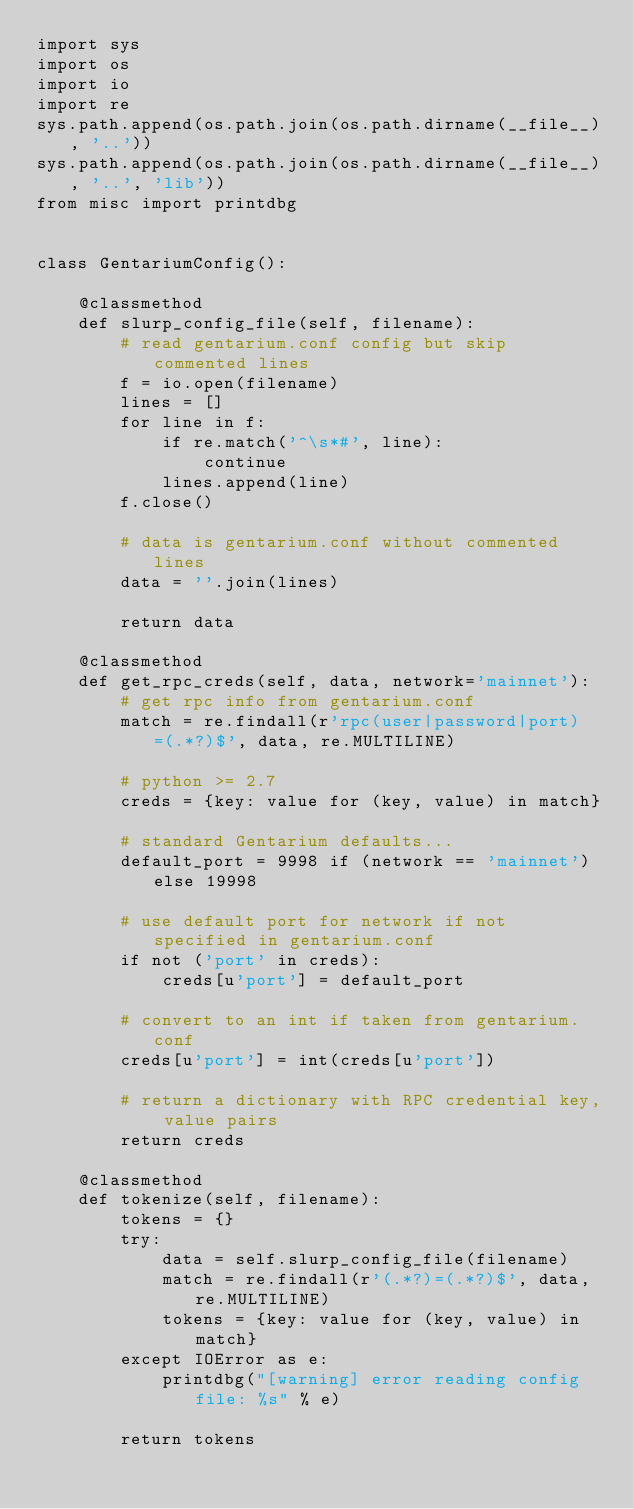<code> <loc_0><loc_0><loc_500><loc_500><_Python_>import sys
import os
import io
import re
sys.path.append(os.path.join(os.path.dirname(__file__), '..'))
sys.path.append(os.path.join(os.path.dirname(__file__), '..', 'lib'))
from misc import printdbg


class GentariumConfig():

    @classmethod
    def slurp_config_file(self, filename):
        # read gentarium.conf config but skip commented lines
        f = io.open(filename)
        lines = []
        for line in f:
            if re.match('^\s*#', line):
                continue
            lines.append(line)
        f.close()

        # data is gentarium.conf without commented lines
        data = ''.join(lines)

        return data

    @classmethod
    def get_rpc_creds(self, data, network='mainnet'):
        # get rpc info from gentarium.conf
        match = re.findall(r'rpc(user|password|port)=(.*?)$', data, re.MULTILINE)

        # python >= 2.7
        creds = {key: value for (key, value) in match}

        # standard Gentarium defaults...
        default_port = 9998 if (network == 'mainnet') else 19998

        # use default port for network if not specified in gentarium.conf
        if not ('port' in creds):
            creds[u'port'] = default_port

        # convert to an int if taken from gentarium.conf
        creds[u'port'] = int(creds[u'port'])

        # return a dictionary with RPC credential key, value pairs
        return creds

    @classmethod
    def tokenize(self, filename):
        tokens = {}
        try:
            data = self.slurp_config_file(filename)
            match = re.findall(r'(.*?)=(.*?)$', data, re.MULTILINE)
            tokens = {key: value for (key, value) in match}
        except IOError as e:
            printdbg("[warning] error reading config file: %s" % e)

        return tokens
</code> 